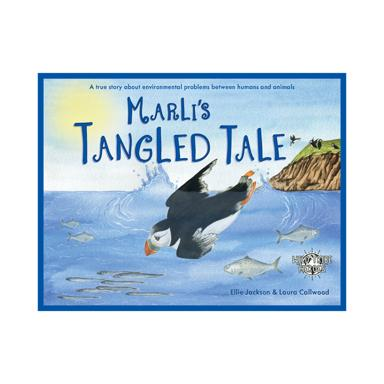What can children learn from 'Marli's Tangled Tale'? Children reading 'Marli's Tangled Tale' can learn about the importance of marine conservation and the harmful effects of human waste on ocean life. It educates young readers on the responsibilities we share in protecting our environment and encourages proactive behavior towards environmental preservation. 